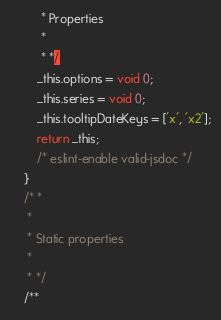Convert code to text. <code><loc_0><loc_0><loc_500><loc_500><_JavaScript_>         * Properties
         *
         * */
        _this.options = void 0;
        _this.series = void 0;
        _this.tooltipDateKeys = ['x', 'x2'];
        return _this;
        /* eslint-enable valid-jsdoc */
    }
    /* *
     *
     * Static properties
     *
     * */
    /**</code> 